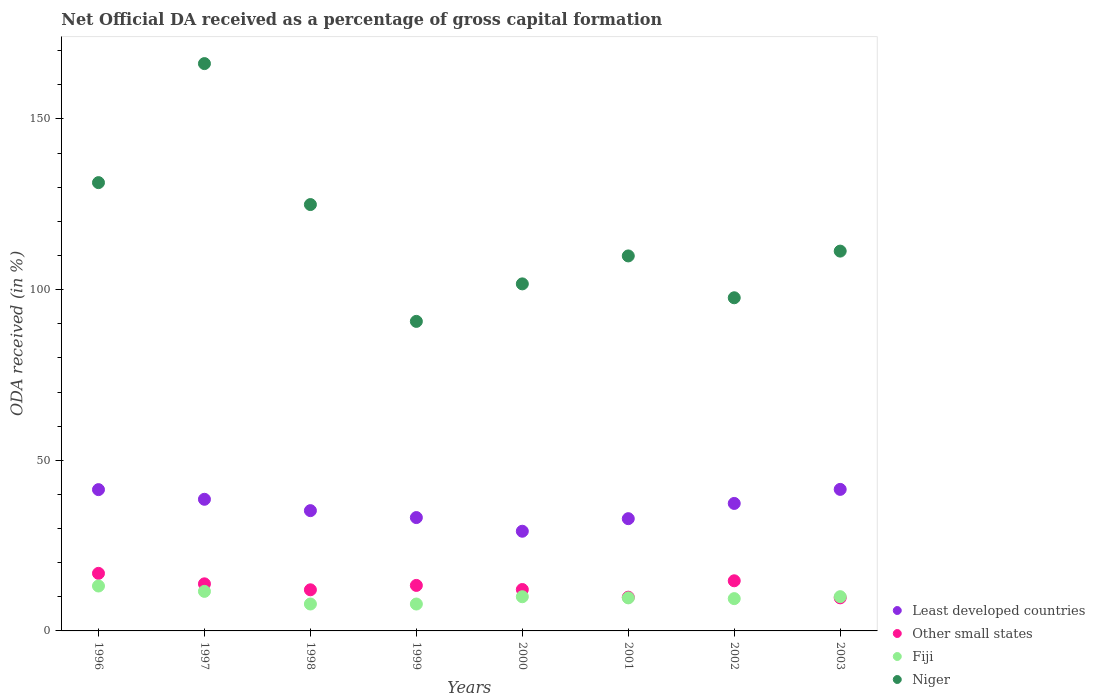Is the number of dotlines equal to the number of legend labels?
Your answer should be very brief. Yes. What is the net ODA received in Least developed countries in 2001?
Your answer should be compact. 32.89. Across all years, what is the maximum net ODA received in Least developed countries?
Your answer should be very brief. 41.47. Across all years, what is the minimum net ODA received in Niger?
Ensure brevity in your answer.  90.69. In which year was the net ODA received in Least developed countries maximum?
Provide a short and direct response. 2003. In which year was the net ODA received in Other small states minimum?
Make the answer very short. 2003. What is the total net ODA received in Other small states in the graph?
Provide a short and direct response. 102.44. What is the difference between the net ODA received in Other small states in 1996 and that in 2001?
Keep it short and to the point. 6.98. What is the difference between the net ODA received in Least developed countries in 2000 and the net ODA received in Fiji in 1996?
Your answer should be very brief. 16.05. What is the average net ODA received in Other small states per year?
Offer a very short reply. 12.8. In the year 1996, what is the difference between the net ODA received in Least developed countries and net ODA received in Other small states?
Provide a succinct answer. 24.53. In how many years, is the net ODA received in Fiji greater than 50 %?
Keep it short and to the point. 0. What is the ratio of the net ODA received in Niger in 1996 to that in 1999?
Offer a very short reply. 1.45. Is the difference between the net ODA received in Least developed countries in 2002 and 2003 greater than the difference between the net ODA received in Other small states in 2002 and 2003?
Provide a short and direct response. No. What is the difference between the highest and the second highest net ODA received in Least developed countries?
Provide a succinct answer. 0.07. What is the difference between the highest and the lowest net ODA received in Least developed countries?
Offer a very short reply. 12.26. In how many years, is the net ODA received in Niger greater than the average net ODA received in Niger taken over all years?
Provide a short and direct response. 3. Is it the case that in every year, the sum of the net ODA received in Niger and net ODA received in Other small states  is greater than the sum of net ODA received in Fiji and net ODA received in Least developed countries?
Ensure brevity in your answer.  Yes. Is it the case that in every year, the sum of the net ODA received in Other small states and net ODA received in Least developed countries  is greater than the net ODA received in Niger?
Offer a very short reply. No. Does the net ODA received in Fiji monotonically increase over the years?
Your answer should be compact. No. Is the net ODA received in Other small states strictly greater than the net ODA received in Niger over the years?
Your answer should be very brief. No. Is the net ODA received in Least developed countries strictly less than the net ODA received in Fiji over the years?
Give a very brief answer. No. How many dotlines are there?
Provide a succinct answer. 4. What is the difference between two consecutive major ticks on the Y-axis?
Provide a short and direct response. 50. Where does the legend appear in the graph?
Offer a very short reply. Bottom right. How many legend labels are there?
Ensure brevity in your answer.  4. How are the legend labels stacked?
Provide a short and direct response. Vertical. What is the title of the graph?
Offer a very short reply. Net Official DA received as a percentage of gross capital formation. Does "Guatemala" appear as one of the legend labels in the graph?
Your answer should be compact. No. What is the label or title of the X-axis?
Provide a short and direct response. Years. What is the label or title of the Y-axis?
Give a very brief answer. ODA received (in %). What is the ODA received (in %) of Least developed countries in 1996?
Ensure brevity in your answer.  41.4. What is the ODA received (in %) in Other small states in 1996?
Provide a succinct answer. 16.87. What is the ODA received (in %) in Fiji in 1996?
Provide a succinct answer. 13.16. What is the ODA received (in %) of Niger in 1996?
Offer a terse response. 131.35. What is the ODA received (in %) in Least developed countries in 1997?
Offer a terse response. 38.57. What is the ODA received (in %) of Other small states in 1997?
Provide a short and direct response. 13.8. What is the ODA received (in %) in Fiji in 1997?
Offer a terse response. 11.59. What is the ODA received (in %) in Niger in 1997?
Ensure brevity in your answer.  166.22. What is the ODA received (in %) in Least developed countries in 1998?
Provide a succinct answer. 35.24. What is the ODA received (in %) in Other small states in 1998?
Ensure brevity in your answer.  12.05. What is the ODA received (in %) of Fiji in 1998?
Keep it short and to the point. 7.89. What is the ODA received (in %) of Niger in 1998?
Offer a very short reply. 124.92. What is the ODA received (in %) in Least developed countries in 1999?
Make the answer very short. 33.21. What is the ODA received (in %) in Other small states in 1999?
Your answer should be compact. 13.33. What is the ODA received (in %) of Fiji in 1999?
Your answer should be very brief. 7.88. What is the ODA received (in %) in Niger in 1999?
Offer a terse response. 90.69. What is the ODA received (in %) in Least developed countries in 2000?
Your answer should be very brief. 29.21. What is the ODA received (in %) of Other small states in 2000?
Ensure brevity in your answer.  12.13. What is the ODA received (in %) in Fiji in 2000?
Your answer should be very brief. 10.02. What is the ODA received (in %) in Niger in 2000?
Give a very brief answer. 101.68. What is the ODA received (in %) of Least developed countries in 2001?
Give a very brief answer. 32.89. What is the ODA received (in %) in Other small states in 2001?
Give a very brief answer. 9.89. What is the ODA received (in %) in Fiji in 2001?
Offer a very short reply. 9.68. What is the ODA received (in %) in Niger in 2001?
Keep it short and to the point. 109.87. What is the ODA received (in %) in Least developed countries in 2002?
Provide a succinct answer. 37.35. What is the ODA received (in %) in Other small states in 2002?
Your answer should be compact. 14.69. What is the ODA received (in %) in Fiji in 2002?
Your answer should be very brief. 9.46. What is the ODA received (in %) of Niger in 2002?
Your answer should be compact. 97.61. What is the ODA received (in %) of Least developed countries in 2003?
Give a very brief answer. 41.47. What is the ODA received (in %) in Other small states in 2003?
Provide a succinct answer. 9.69. What is the ODA received (in %) in Fiji in 2003?
Provide a short and direct response. 10.04. What is the ODA received (in %) of Niger in 2003?
Offer a terse response. 111.28. Across all years, what is the maximum ODA received (in %) in Least developed countries?
Ensure brevity in your answer.  41.47. Across all years, what is the maximum ODA received (in %) in Other small states?
Offer a terse response. 16.87. Across all years, what is the maximum ODA received (in %) in Fiji?
Your response must be concise. 13.16. Across all years, what is the maximum ODA received (in %) in Niger?
Offer a very short reply. 166.22. Across all years, what is the minimum ODA received (in %) of Least developed countries?
Give a very brief answer. 29.21. Across all years, what is the minimum ODA received (in %) in Other small states?
Offer a very short reply. 9.69. Across all years, what is the minimum ODA received (in %) of Fiji?
Your response must be concise. 7.88. Across all years, what is the minimum ODA received (in %) in Niger?
Provide a succinct answer. 90.69. What is the total ODA received (in %) of Least developed countries in the graph?
Offer a terse response. 289.34. What is the total ODA received (in %) of Other small states in the graph?
Make the answer very short. 102.44. What is the total ODA received (in %) of Fiji in the graph?
Provide a short and direct response. 79.71. What is the total ODA received (in %) in Niger in the graph?
Make the answer very short. 933.63. What is the difference between the ODA received (in %) of Least developed countries in 1996 and that in 1997?
Your response must be concise. 2.83. What is the difference between the ODA received (in %) of Other small states in 1996 and that in 1997?
Make the answer very short. 3.07. What is the difference between the ODA received (in %) of Fiji in 1996 and that in 1997?
Keep it short and to the point. 1.57. What is the difference between the ODA received (in %) in Niger in 1996 and that in 1997?
Offer a terse response. -34.87. What is the difference between the ODA received (in %) in Least developed countries in 1996 and that in 1998?
Offer a terse response. 6.16. What is the difference between the ODA received (in %) in Other small states in 1996 and that in 1998?
Make the answer very short. 4.82. What is the difference between the ODA received (in %) in Fiji in 1996 and that in 1998?
Make the answer very short. 5.27. What is the difference between the ODA received (in %) in Niger in 1996 and that in 1998?
Ensure brevity in your answer.  6.43. What is the difference between the ODA received (in %) of Least developed countries in 1996 and that in 1999?
Ensure brevity in your answer.  8.19. What is the difference between the ODA received (in %) in Other small states in 1996 and that in 1999?
Ensure brevity in your answer.  3.53. What is the difference between the ODA received (in %) in Fiji in 1996 and that in 1999?
Give a very brief answer. 5.28. What is the difference between the ODA received (in %) in Niger in 1996 and that in 1999?
Keep it short and to the point. 40.66. What is the difference between the ODA received (in %) in Least developed countries in 1996 and that in 2000?
Keep it short and to the point. 12.19. What is the difference between the ODA received (in %) in Other small states in 1996 and that in 2000?
Your response must be concise. 4.74. What is the difference between the ODA received (in %) of Fiji in 1996 and that in 2000?
Your response must be concise. 3.14. What is the difference between the ODA received (in %) of Niger in 1996 and that in 2000?
Ensure brevity in your answer.  29.67. What is the difference between the ODA received (in %) in Least developed countries in 1996 and that in 2001?
Offer a terse response. 8.51. What is the difference between the ODA received (in %) of Other small states in 1996 and that in 2001?
Provide a succinct answer. 6.98. What is the difference between the ODA received (in %) of Fiji in 1996 and that in 2001?
Give a very brief answer. 3.47. What is the difference between the ODA received (in %) in Niger in 1996 and that in 2001?
Keep it short and to the point. 21.48. What is the difference between the ODA received (in %) of Least developed countries in 1996 and that in 2002?
Your response must be concise. 4.05. What is the difference between the ODA received (in %) of Other small states in 1996 and that in 2002?
Your answer should be compact. 2.18. What is the difference between the ODA received (in %) in Fiji in 1996 and that in 2002?
Keep it short and to the point. 3.7. What is the difference between the ODA received (in %) in Niger in 1996 and that in 2002?
Offer a very short reply. 33.74. What is the difference between the ODA received (in %) of Least developed countries in 1996 and that in 2003?
Keep it short and to the point. -0.07. What is the difference between the ODA received (in %) of Other small states in 1996 and that in 2003?
Provide a succinct answer. 7.17. What is the difference between the ODA received (in %) of Fiji in 1996 and that in 2003?
Your answer should be very brief. 3.12. What is the difference between the ODA received (in %) of Niger in 1996 and that in 2003?
Your response must be concise. 20.07. What is the difference between the ODA received (in %) of Least developed countries in 1997 and that in 1998?
Keep it short and to the point. 3.33. What is the difference between the ODA received (in %) of Other small states in 1997 and that in 1998?
Offer a terse response. 1.75. What is the difference between the ODA received (in %) in Fiji in 1997 and that in 1998?
Offer a terse response. 3.7. What is the difference between the ODA received (in %) in Niger in 1997 and that in 1998?
Offer a terse response. 41.3. What is the difference between the ODA received (in %) of Least developed countries in 1997 and that in 1999?
Your answer should be very brief. 5.36. What is the difference between the ODA received (in %) in Other small states in 1997 and that in 1999?
Provide a short and direct response. 0.46. What is the difference between the ODA received (in %) of Fiji in 1997 and that in 1999?
Offer a very short reply. 3.71. What is the difference between the ODA received (in %) in Niger in 1997 and that in 1999?
Make the answer very short. 75.53. What is the difference between the ODA received (in %) of Least developed countries in 1997 and that in 2000?
Your response must be concise. 9.36. What is the difference between the ODA received (in %) in Other small states in 1997 and that in 2000?
Make the answer very short. 1.67. What is the difference between the ODA received (in %) of Fiji in 1997 and that in 2000?
Keep it short and to the point. 1.57. What is the difference between the ODA received (in %) of Niger in 1997 and that in 2000?
Your answer should be compact. 64.54. What is the difference between the ODA received (in %) of Least developed countries in 1997 and that in 2001?
Keep it short and to the point. 5.68. What is the difference between the ODA received (in %) of Other small states in 1997 and that in 2001?
Your answer should be compact. 3.91. What is the difference between the ODA received (in %) in Fiji in 1997 and that in 2001?
Your answer should be compact. 1.91. What is the difference between the ODA received (in %) of Niger in 1997 and that in 2001?
Your answer should be compact. 56.35. What is the difference between the ODA received (in %) of Least developed countries in 1997 and that in 2002?
Make the answer very short. 1.22. What is the difference between the ODA received (in %) in Other small states in 1997 and that in 2002?
Offer a very short reply. -0.89. What is the difference between the ODA received (in %) in Fiji in 1997 and that in 2002?
Ensure brevity in your answer.  2.13. What is the difference between the ODA received (in %) in Niger in 1997 and that in 2002?
Give a very brief answer. 68.61. What is the difference between the ODA received (in %) of Least developed countries in 1997 and that in 2003?
Make the answer very short. -2.9. What is the difference between the ODA received (in %) of Other small states in 1997 and that in 2003?
Your response must be concise. 4.1. What is the difference between the ODA received (in %) in Fiji in 1997 and that in 2003?
Provide a short and direct response. 1.55. What is the difference between the ODA received (in %) of Niger in 1997 and that in 2003?
Give a very brief answer. 54.94. What is the difference between the ODA received (in %) of Least developed countries in 1998 and that in 1999?
Give a very brief answer. 2.03. What is the difference between the ODA received (in %) in Other small states in 1998 and that in 1999?
Give a very brief answer. -1.28. What is the difference between the ODA received (in %) of Fiji in 1998 and that in 1999?
Offer a very short reply. 0.01. What is the difference between the ODA received (in %) of Niger in 1998 and that in 1999?
Your answer should be compact. 34.23. What is the difference between the ODA received (in %) in Least developed countries in 1998 and that in 2000?
Your answer should be very brief. 6.04. What is the difference between the ODA received (in %) of Other small states in 1998 and that in 2000?
Give a very brief answer. -0.08. What is the difference between the ODA received (in %) in Fiji in 1998 and that in 2000?
Keep it short and to the point. -2.13. What is the difference between the ODA received (in %) in Niger in 1998 and that in 2000?
Provide a succinct answer. 23.24. What is the difference between the ODA received (in %) in Least developed countries in 1998 and that in 2001?
Your response must be concise. 2.35. What is the difference between the ODA received (in %) of Other small states in 1998 and that in 2001?
Offer a very short reply. 2.16. What is the difference between the ODA received (in %) in Fiji in 1998 and that in 2001?
Your answer should be very brief. -1.8. What is the difference between the ODA received (in %) in Niger in 1998 and that in 2001?
Ensure brevity in your answer.  15.05. What is the difference between the ODA received (in %) of Least developed countries in 1998 and that in 2002?
Your response must be concise. -2.11. What is the difference between the ODA received (in %) in Other small states in 1998 and that in 2002?
Provide a short and direct response. -2.64. What is the difference between the ODA received (in %) of Fiji in 1998 and that in 2002?
Provide a short and direct response. -1.58. What is the difference between the ODA received (in %) of Niger in 1998 and that in 2002?
Keep it short and to the point. 27.31. What is the difference between the ODA received (in %) in Least developed countries in 1998 and that in 2003?
Your response must be concise. -6.23. What is the difference between the ODA received (in %) in Other small states in 1998 and that in 2003?
Offer a terse response. 2.36. What is the difference between the ODA received (in %) of Fiji in 1998 and that in 2003?
Keep it short and to the point. -2.15. What is the difference between the ODA received (in %) of Niger in 1998 and that in 2003?
Your answer should be compact. 13.64. What is the difference between the ODA received (in %) of Least developed countries in 1999 and that in 2000?
Keep it short and to the point. 4.01. What is the difference between the ODA received (in %) of Other small states in 1999 and that in 2000?
Your answer should be very brief. 1.2. What is the difference between the ODA received (in %) in Fiji in 1999 and that in 2000?
Your answer should be compact. -2.14. What is the difference between the ODA received (in %) in Niger in 1999 and that in 2000?
Your answer should be compact. -10.99. What is the difference between the ODA received (in %) of Least developed countries in 1999 and that in 2001?
Provide a short and direct response. 0.32. What is the difference between the ODA received (in %) of Other small states in 1999 and that in 2001?
Keep it short and to the point. 3.45. What is the difference between the ODA received (in %) in Fiji in 1999 and that in 2001?
Your answer should be compact. -1.8. What is the difference between the ODA received (in %) of Niger in 1999 and that in 2001?
Your response must be concise. -19.18. What is the difference between the ODA received (in %) of Least developed countries in 1999 and that in 2002?
Give a very brief answer. -4.14. What is the difference between the ODA received (in %) in Other small states in 1999 and that in 2002?
Your answer should be compact. -1.36. What is the difference between the ODA received (in %) of Fiji in 1999 and that in 2002?
Provide a succinct answer. -1.58. What is the difference between the ODA received (in %) in Niger in 1999 and that in 2002?
Your answer should be compact. -6.92. What is the difference between the ODA received (in %) in Least developed countries in 1999 and that in 2003?
Provide a short and direct response. -8.26. What is the difference between the ODA received (in %) in Other small states in 1999 and that in 2003?
Make the answer very short. 3.64. What is the difference between the ODA received (in %) of Fiji in 1999 and that in 2003?
Your answer should be compact. -2.16. What is the difference between the ODA received (in %) of Niger in 1999 and that in 2003?
Keep it short and to the point. -20.59. What is the difference between the ODA received (in %) in Least developed countries in 2000 and that in 2001?
Give a very brief answer. -3.68. What is the difference between the ODA received (in %) in Other small states in 2000 and that in 2001?
Make the answer very short. 2.24. What is the difference between the ODA received (in %) of Fiji in 2000 and that in 2001?
Ensure brevity in your answer.  0.33. What is the difference between the ODA received (in %) of Niger in 2000 and that in 2001?
Provide a short and direct response. -8.19. What is the difference between the ODA received (in %) in Least developed countries in 2000 and that in 2002?
Make the answer very short. -8.15. What is the difference between the ODA received (in %) in Other small states in 2000 and that in 2002?
Your answer should be very brief. -2.56. What is the difference between the ODA received (in %) in Fiji in 2000 and that in 2002?
Offer a terse response. 0.55. What is the difference between the ODA received (in %) of Niger in 2000 and that in 2002?
Make the answer very short. 4.07. What is the difference between the ODA received (in %) in Least developed countries in 2000 and that in 2003?
Offer a terse response. -12.26. What is the difference between the ODA received (in %) in Other small states in 2000 and that in 2003?
Your answer should be compact. 2.43. What is the difference between the ODA received (in %) in Fiji in 2000 and that in 2003?
Give a very brief answer. -0.02. What is the difference between the ODA received (in %) of Niger in 2000 and that in 2003?
Ensure brevity in your answer.  -9.6. What is the difference between the ODA received (in %) in Least developed countries in 2001 and that in 2002?
Your response must be concise. -4.47. What is the difference between the ODA received (in %) of Other small states in 2001 and that in 2002?
Offer a terse response. -4.8. What is the difference between the ODA received (in %) of Fiji in 2001 and that in 2002?
Your response must be concise. 0.22. What is the difference between the ODA received (in %) of Niger in 2001 and that in 2002?
Your answer should be compact. 12.26. What is the difference between the ODA received (in %) of Least developed countries in 2001 and that in 2003?
Offer a very short reply. -8.58. What is the difference between the ODA received (in %) of Other small states in 2001 and that in 2003?
Offer a very short reply. 0.19. What is the difference between the ODA received (in %) of Fiji in 2001 and that in 2003?
Give a very brief answer. -0.35. What is the difference between the ODA received (in %) of Niger in 2001 and that in 2003?
Give a very brief answer. -1.41. What is the difference between the ODA received (in %) of Least developed countries in 2002 and that in 2003?
Offer a terse response. -4.11. What is the difference between the ODA received (in %) in Other small states in 2002 and that in 2003?
Offer a very short reply. 5. What is the difference between the ODA received (in %) in Fiji in 2002 and that in 2003?
Provide a succinct answer. -0.57. What is the difference between the ODA received (in %) of Niger in 2002 and that in 2003?
Make the answer very short. -13.67. What is the difference between the ODA received (in %) of Least developed countries in 1996 and the ODA received (in %) of Other small states in 1997?
Your answer should be very brief. 27.6. What is the difference between the ODA received (in %) of Least developed countries in 1996 and the ODA received (in %) of Fiji in 1997?
Your answer should be compact. 29.81. What is the difference between the ODA received (in %) of Least developed countries in 1996 and the ODA received (in %) of Niger in 1997?
Make the answer very short. -124.82. What is the difference between the ODA received (in %) in Other small states in 1996 and the ODA received (in %) in Fiji in 1997?
Your answer should be very brief. 5.28. What is the difference between the ODA received (in %) in Other small states in 1996 and the ODA received (in %) in Niger in 1997?
Keep it short and to the point. -149.36. What is the difference between the ODA received (in %) in Fiji in 1996 and the ODA received (in %) in Niger in 1997?
Offer a very short reply. -153.06. What is the difference between the ODA received (in %) of Least developed countries in 1996 and the ODA received (in %) of Other small states in 1998?
Give a very brief answer. 29.35. What is the difference between the ODA received (in %) of Least developed countries in 1996 and the ODA received (in %) of Fiji in 1998?
Ensure brevity in your answer.  33.51. What is the difference between the ODA received (in %) of Least developed countries in 1996 and the ODA received (in %) of Niger in 1998?
Your answer should be compact. -83.52. What is the difference between the ODA received (in %) of Other small states in 1996 and the ODA received (in %) of Fiji in 1998?
Make the answer very short. 8.98. What is the difference between the ODA received (in %) of Other small states in 1996 and the ODA received (in %) of Niger in 1998?
Your answer should be very brief. -108.06. What is the difference between the ODA received (in %) in Fiji in 1996 and the ODA received (in %) in Niger in 1998?
Give a very brief answer. -111.76. What is the difference between the ODA received (in %) in Least developed countries in 1996 and the ODA received (in %) in Other small states in 1999?
Make the answer very short. 28.07. What is the difference between the ODA received (in %) of Least developed countries in 1996 and the ODA received (in %) of Fiji in 1999?
Your response must be concise. 33.52. What is the difference between the ODA received (in %) in Least developed countries in 1996 and the ODA received (in %) in Niger in 1999?
Give a very brief answer. -49.29. What is the difference between the ODA received (in %) of Other small states in 1996 and the ODA received (in %) of Fiji in 1999?
Your answer should be very brief. 8.99. What is the difference between the ODA received (in %) in Other small states in 1996 and the ODA received (in %) in Niger in 1999?
Your answer should be very brief. -73.83. What is the difference between the ODA received (in %) of Fiji in 1996 and the ODA received (in %) of Niger in 1999?
Your answer should be very brief. -77.53. What is the difference between the ODA received (in %) of Least developed countries in 1996 and the ODA received (in %) of Other small states in 2000?
Keep it short and to the point. 29.27. What is the difference between the ODA received (in %) in Least developed countries in 1996 and the ODA received (in %) in Fiji in 2000?
Give a very brief answer. 31.38. What is the difference between the ODA received (in %) in Least developed countries in 1996 and the ODA received (in %) in Niger in 2000?
Offer a terse response. -60.28. What is the difference between the ODA received (in %) of Other small states in 1996 and the ODA received (in %) of Fiji in 2000?
Give a very brief answer. 6.85. What is the difference between the ODA received (in %) of Other small states in 1996 and the ODA received (in %) of Niger in 2000?
Give a very brief answer. -84.82. What is the difference between the ODA received (in %) of Fiji in 1996 and the ODA received (in %) of Niger in 2000?
Give a very brief answer. -88.52. What is the difference between the ODA received (in %) of Least developed countries in 1996 and the ODA received (in %) of Other small states in 2001?
Make the answer very short. 31.51. What is the difference between the ODA received (in %) in Least developed countries in 1996 and the ODA received (in %) in Fiji in 2001?
Provide a succinct answer. 31.71. What is the difference between the ODA received (in %) in Least developed countries in 1996 and the ODA received (in %) in Niger in 2001?
Your answer should be compact. -68.47. What is the difference between the ODA received (in %) of Other small states in 1996 and the ODA received (in %) of Fiji in 2001?
Ensure brevity in your answer.  7.18. What is the difference between the ODA received (in %) of Other small states in 1996 and the ODA received (in %) of Niger in 2001?
Keep it short and to the point. -93.01. What is the difference between the ODA received (in %) in Fiji in 1996 and the ODA received (in %) in Niger in 2001?
Make the answer very short. -96.71. What is the difference between the ODA received (in %) in Least developed countries in 1996 and the ODA received (in %) in Other small states in 2002?
Ensure brevity in your answer.  26.71. What is the difference between the ODA received (in %) in Least developed countries in 1996 and the ODA received (in %) in Fiji in 2002?
Make the answer very short. 31.94. What is the difference between the ODA received (in %) of Least developed countries in 1996 and the ODA received (in %) of Niger in 2002?
Give a very brief answer. -56.21. What is the difference between the ODA received (in %) in Other small states in 1996 and the ODA received (in %) in Fiji in 2002?
Your answer should be compact. 7.4. What is the difference between the ODA received (in %) in Other small states in 1996 and the ODA received (in %) in Niger in 2002?
Your answer should be very brief. -80.75. What is the difference between the ODA received (in %) of Fiji in 1996 and the ODA received (in %) of Niger in 2002?
Provide a short and direct response. -84.45. What is the difference between the ODA received (in %) of Least developed countries in 1996 and the ODA received (in %) of Other small states in 2003?
Provide a succinct answer. 31.71. What is the difference between the ODA received (in %) in Least developed countries in 1996 and the ODA received (in %) in Fiji in 2003?
Your answer should be compact. 31.36. What is the difference between the ODA received (in %) in Least developed countries in 1996 and the ODA received (in %) in Niger in 2003?
Provide a short and direct response. -69.88. What is the difference between the ODA received (in %) in Other small states in 1996 and the ODA received (in %) in Fiji in 2003?
Offer a very short reply. 6.83. What is the difference between the ODA received (in %) in Other small states in 1996 and the ODA received (in %) in Niger in 2003?
Offer a very short reply. -94.42. What is the difference between the ODA received (in %) of Fiji in 1996 and the ODA received (in %) of Niger in 2003?
Ensure brevity in your answer.  -98.12. What is the difference between the ODA received (in %) of Least developed countries in 1997 and the ODA received (in %) of Other small states in 1998?
Ensure brevity in your answer.  26.52. What is the difference between the ODA received (in %) of Least developed countries in 1997 and the ODA received (in %) of Fiji in 1998?
Provide a short and direct response. 30.68. What is the difference between the ODA received (in %) of Least developed countries in 1997 and the ODA received (in %) of Niger in 1998?
Your answer should be very brief. -86.35. What is the difference between the ODA received (in %) of Other small states in 1997 and the ODA received (in %) of Fiji in 1998?
Give a very brief answer. 5.91. What is the difference between the ODA received (in %) of Other small states in 1997 and the ODA received (in %) of Niger in 1998?
Give a very brief answer. -111.13. What is the difference between the ODA received (in %) in Fiji in 1997 and the ODA received (in %) in Niger in 1998?
Give a very brief answer. -113.33. What is the difference between the ODA received (in %) of Least developed countries in 1997 and the ODA received (in %) of Other small states in 1999?
Offer a very short reply. 25.24. What is the difference between the ODA received (in %) of Least developed countries in 1997 and the ODA received (in %) of Fiji in 1999?
Provide a short and direct response. 30.69. What is the difference between the ODA received (in %) in Least developed countries in 1997 and the ODA received (in %) in Niger in 1999?
Make the answer very short. -52.12. What is the difference between the ODA received (in %) of Other small states in 1997 and the ODA received (in %) of Fiji in 1999?
Make the answer very short. 5.92. What is the difference between the ODA received (in %) of Other small states in 1997 and the ODA received (in %) of Niger in 1999?
Give a very brief answer. -76.9. What is the difference between the ODA received (in %) in Fiji in 1997 and the ODA received (in %) in Niger in 1999?
Offer a terse response. -79.1. What is the difference between the ODA received (in %) in Least developed countries in 1997 and the ODA received (in %) in Other small states in 2000?
Make the answer very short. 26.44. What is the difference between the ODA received (in %) in Least developed countries in 1997 and the ODA received (in %) in Fiji in 2000?
Offer a terse response. 28.55. What is the difference between the ODA received (in %) of Least developed countries in 1997 and the ODA received (in %) of Niger in 2000?
Your answer should be compact. -63.11. What is the difference between the ODA received (in %) of Other small states in 1997 and the ODA received (in %) of Fiji in 2000?
Ensure brevity in your answer.  3.78. What is the difference between the ODA received (in %) of Other small states in 1997 and the ODA received (in %) of Niger in 2000?
Offer a very short reply. -87.89. What is the difference between the ODA received (in %) of Fiji in 1997 and the ODA received (in %) of Niger in 2000?
Ensure brevity in your answer.  -90.09. What is the difference between the ODA received (in %) in Least developed countries in 1997 and the ODA received (in %) in Other small states in 2001?
Offer a terse response. 28.68. What is the difference between the ODA received (in %) in Least developed countries in 1997 and the ODA received (in %) in Fiji in 2001?
Your answer should be very brief. 28.89. What is the difference between the ODA received (in %) in Least developed countries in 1997 and the ODA received (in %) in Niger in 2001?
Your answer should be compact. -71.3. What is the difference between the ODA received (in %) in Other small states in 1997 and the ODA received (in %) in Fiji in 2001?
Keep it short and to the point. 4.11. What is the difference between the ODA received (in %) of Other small states in 1997 and the ODA received (in %) of Niger in 2001?
Your answer should be compact. -96.07. What is the difference between the ODA received (in %) in Fiji in 1997 and the ODA received (in %) in Niger in 2001?
Provide a succinct answer. -98.28. What is the difference between the ODA received (in %) of Least developed countries in 1997 and the ODA received (in %) of Other small states in 2002?
Ensure brevity in your answer.  23.88. What is the difference between the ODA received (in %) of Least developed countries in 1997 and the ODA received (in %) of Fiji in 2002?
Offer a terse response. 29.11. What is the difference between the ODA received (in %) in Least developed countries in 1997 and the ODA received (in %) in Niger in 2002?
Your response must be concise. -59.04. What is the difference between the ODA received (in %) of Other small states in 1997 and the ODA received (in %) of Fiji in 2002?
Make the answer very short. 4.33. What is the difference between the ODA received (in %) of Other small states in 1997 and the ODA received (in %) of Niger in 2002?
Your response must be concise. -83.82. What is the difference between the ODA received (in %) in Fiji in 1997 and the ODA received (in %) in Niger in 2002?
Your answer should be compact. -86.02. What is the difference between the ODA received (in %) in Least developed countries in 1997 and the ODA received (in %) in Other small states in 2003?
Provide a succinct answer. 28.88. What is the difference between the ODA received (in %) in Least developed countries in 1997 and the ODA received (in %) in Fiji in 2003?
Provide a short and direct response. 28.53. What is the difference between the ODA received (in %) of Least developed countries in 1997 and the ODA received (in %) of Niger in 2003?
Give a very brief answer. -72.71. What is the difference between the ODA received (in %) in Other small states in 1997 and the ODA received (in %) in Fiji in 2003?
Your response must be concise. 3.76. What is the difference between the ODA received (in %) of Other small states in 1997 and the ODA received (in %) of Niger in 2003?
Provide a short and direct response. -97.49. What is the difference between the ODA received (in %) in Fiji in 1997 and the ODA received (in %) in Niger in 2003?
Offer a very short reply. -99.69. What is the difference between the ODA received (in %) of Least developed countries in 1998 and the ODA received (in %) of Other small states in 1999?
Make the answer very short. 21.91. What is the difference between the ODA received (in %) of Least developed countries in 1998 and the ODA received (in %) of Fiji in 1999?
Make the answer very short. 27.36. What is the difference between the ODA received (in %) in Least developed countries in 1998 and the ODA received (in %) in Niger in 1999?
Provide a short and direct response. -55.45. What is the difference between the ODA received (in %) of Other small states in 1998 and the ODA received (in %) of Fiji in 1999?
Your response must be concise. 4.17. What is the difference between the ODA received (in %) of Other small states in 1998 and the ODA received (in %) of Niger in 1999?
Your response must be concise. -78.64. What is the difference between the ODA received (in %) of Fiji in 1998 and the ODA received (in %) of Niger in 1999?
Ensure brevity in your answer.  -82.81. What is the difference between the ODA received (in %) in Least developed countries in 1998 and the ODA received (in %) in Other small states in 2000?
Provide a succinct answer. 23.11. What is the difference between the ODA received (in %) in Least developed countries in 1998 and the ODA received (in %) in Fiji in 2000?
Your answer should be compact. 25.22. What is the difference between the ODA received (in %) in Least developed countries in 1998 and the ODA received (in %) in Niger in 2000?
Provide a short and direct response. -66.44. What is the difference between the ODA received (in %) of Other small states in 1998 and the ODA received (in %) of Fiji in 2000?
Your answer should be very brief. 2.03. What is the difference between the ODA received (in %) in Other small states in 1998 and the ODA received (in %) in Niger in 2000?
Offer a terse response. -89.63. What is the difference between the ODA received (in %) of Fiji in 1998 and the ODA received (in %) of Niger in 2000?
Offer a very short reply. -93.8. What is the difference between the ODA received (in %) in Least developed countries in 1998 and the ODA received (in %) in Other small states in 2001?
Ensure brevity in your answer.  25.35. What is the difference between the ODA received (in %) of Least developed countries in 1998 and the ODA received (in %) of Fiji in 2001?
Your answer should be compact. 25.56. What is the difference between the ODA received (in %) in Least developed countries in 1998 and the ODA received (in %) in Niger in 2001?
Offer a very short reply. -74.63. What is the difference between the ODA received (in %) of Other small states in 1998 and the ODA received (in %) of Fiji in 2001?
Ensure brevity in your answer.  2.36. What is the difference between the ODA received (in %) in Other small states in 1998 and the ODA received (in %) in Niger in 2001?
Offer a very short reply. -97.82. What is the difference between the ODA received (in %) in Fiji in 1998 and the ODA received (in %) in Niger in 2001?
Keep it short and to the point. -101.98. What is the difference between the ODA received (in %) of Least developed countries in 1998 and the ODA received (in %) of Other small states in 2002?
Ensure brevity in your answer.  20.55. What is the difference between the ODA received (in %) of Least developed countries in 1998 and the ODA received (in %) of Fiji in 2002?
Offer a very short reply. 25.78. What is the difference between the ODA received (in %) of Least developed countries in 1998 and the ODA received (in %) of Niger in 2002?
Provide a short and direct response. -62.37. What is the difference between the ODA received (in %) of Other small states in 1998 and the ODA received (in %) of Fiji in 2002?
Offer a terse response. 2.59. What is the difference between the ODA received (in %) in Other small states in 1998 and the ODA received (in %) in Niger in 2002?
Your answer should be very brief. -85.56. What is the difference between the ODA received (in %) in Fiji in 1998 and the ODA received (in %) in Niger in 2002?
Your response must be concise. -89.73. What is the difference between the ODA received (in %) in Least developed countries in 1998 and the ODA received (in %) in Other small states in 2003?
Your response must be concise. 25.55. What is the difference between the ODA received (in %) in Least developed countries in 1998 and the ODA received (in %) in Fiji in 2003?
Offer a very short reply. 25.21. What is the difference between the ODA received (in %) in Least developed countries in 1998 and the ODA received (in %) in Niger in 2003?
Give a very brief answer. -76.04. What is the difference between the ODA received (in %) in Other small states in 1998 and the ODA received (in %) in Fiji in 2003?
Your response must be concise. 2.01. What is the difference between the ODA received (in %) of Other small states in 1998 and the ODA received (in %) of Niger in 2003?
Provide a short and direct response. -99.23. What is the difference between the ODA received (in %) of Fiji in 1998 and the ODA received (in %) of Niger in 2003?
Keep it short and to the point. -103.4. What is the difference between the ODA received (in %) of Least developed countries in 1999 and the ODA received (in %) of Other small states in 2000?
Offer a terse response. 21.08. What is the difference between the ODA received (in %) of Least developed countries in 1999 and the ODA received (in %) of Fiji in 2000?
Give a very brief answer. 23.2. What is the difference between the ODA received (in %) of Least developed countries in 1999 and the ODA received (in %) of Niger in 2000?
Keep it short and to the point. -68.47. What is the difference between the ODA received (in %) in Other small states in 1999 and the ODA received (in %) in Fiji in 2000?
Give a very brief answer. 3.32. What is the difference between the ODA received (in %) in Other small states in 1999 and the ODA received (in %) in Niger in 2000?
Provide a short and direct response. -88.35. What is the difference between the ODA received (in %) of Fiji in 1999 and the ODA received (in %) of Niger in 2000?
Give a very brief answer. -93.8. What is the difference between the ODA received (in %) in Least developed countries in 1999 and the ODA received (in %) in Other small states in 2001?
Offer a very short reply. 23.33. What is the difference between the ODA received (in %) of Least developed countries in 1999 and the ODA received (in %) of Fiji in 2001?
Ensure brevity in your answer.  23.53. What is the difference between the ODA received (in %) of Least developed countries in 1999 and the ODA received (in %) of Niger in 2001?
Provide a succinct answer. -76.66. What is the difference between the ODA received (in %) of Other small states in 1999 and the ODA received (in %) of Fiji in 2001?
Your response must be concise. 3.65. What is the difference between the ODA received (in %) of Other small states in 1999 and the ODA received (in %) of Niger in 2001?
Make the answer very short. -96.54. What is the difference between the ODA received (in %) of Fiji in 1999 and the ODA received (in %) of Niger in 2001?
Your answer should be very brief. -101.99. What is the difference between the ODA received (in %) of Least developed countries in 1999 and the ODA received (in %) of Other small states in 2002?
Keep it short and to the point. 18.52. What is the difference between the ODA received (in %) in Least developed countries in 1999 and the ODA received (in %) in Fiji in 2002?
Keep it short and to the point. 23.75. What is the difference between the ODA received (in %) of Least developed countries in 1999 and the ODA received (in %) of Niger in 2002?
Provide a short and direct response. -64.4. What is the difference between the ODA received (in %) of Other small states in 1999 and the ODA received (in %) of Fiji in 2002?
Make the answer very short. 3.87. What is the difference between the ODA received (in %) in Other small states in 1999 and the ODA received (in %) in Niger in 2002?
Offer a terse response. -84.28. What is the difference between the ODA received (in %) in Fiji in 1999 and the ODA received (in %) in Niger in 2002?
Give a very brief answer. -89.73. What is the difference between the ODA received (in %) in Least developed countries in 1999 and the ODA received (in %) in Other small states in 2003?
Offer a very short reply. 23.52. What is the difference between the ODA received (in %) of Least developed countries in 1999 and the ODA received (in %) of Fiji in 2003?
Your answer should be very brief. 23.18. What is the difference between the ODA received (in %) in Least developed countries in 1999 and the ODA received (in %) in Niger in 2003?
Give a very brief answer. -78.07. What is the difference between the ODA received (in %) in Other small states in 1999 and the ODA received (in %) in Fiji in 2003?
Provide a short and direct response. 3.3. What is the difference between the ODA received (in %) of Other small states in 1999 and the ODA received (in %) of Niger in 2003?
Keep it short and to the point. -97.95. What is the difference between the ODA received (in %) of Fiji in 1999 and the ODA received (in %) of Niger in 2003?
Your answer should be very brief. -103.4. What is the difference between the ODA received (in %) in Least developed countries in 2000 and the ODA received (in %) in Other small states in 2001?
Ensure brevity in your answer.  19.32. What is the difference between the ODA received (in %) in Least developed countries in 2000 and the ODA received (in %) in Fiji in 2001?
Offer a very short reply. 19.52. What is the difference between the ODA received (in %) in Least developed countries in 2000 and the ODA received (in %) in Niger in 2001?
Provide a succinct answer. -80.67. What is the difference between the ODA received (in %) of Other small states in 2000 and the ODA received (in %) of Fiji in 2001?
Make the answer very short. 2.44. What is the difference between the ODA received (in %) in Other small states in 2000 and the ODA received (in %) in Niger in 2001?
Your answer should be compact. -97.74. What is the difference between the ODA received (in %) of Fiji in 2000 and the ODA received (in %) of Niger in 2001?
Provide a succinct answer. -99.85. What is the difference between the ODA received (in %) in Least developed countries in 2000 and the ODA received (in %) in Other small states in 2002?
Your response must be concise. 14.52. What is the difference between the ODA received (in %) in Least developed countries in 2000 and the ODA received (in %) in Fiji in 2002?
Provide a short and direct response. 19.74. What is the difference between the ODA received (in %) in Least developed countries in 2000 and the ODA received (in %) in Niger in 2002?
Provide a short and direct response. -68.41. What is the difference between the ODA received (in %) in Other small states in 2000 and the ODA received (in %) in Fiji in 2002?
Your answer should be very brief. 2.67. What is the difference between the ODA received (in %) in Other small states in 2000 and the ODA received (in %) in Niger in 2002?
Your response must be concise. -85.48. What is the difference between the ODA received (in %) in Fiji in 2000 and the ODA received (in %) in Niger in 2002?
Your answer should be very brief. -87.6. What is the difference between the ODA received (in %) in Least developed countries in 2000 and the ODA received (in %) in Other small states in 2003?
Your answer should be very brief. 19.51. What is the difference between the ODA received (in %) in Least developed countries in 2000 and the ODA received (in %) in Fiji in 2003?
Your answer should be compact. 19.17. What is the difference between the ODA received (in %) of Least developed countries in 2000 and the ODA received (in %) of Niger in 2003?
Keep it short and to the point. -82.08. What is the difference between the ODA received (in %) of Other small states in 2000 and the ODA received (in %) of Fiji in 2003?
Make the answer very short. 2.09. What is the difference between the ODA received (in %) of Other small states in 2000 and the ODA received (in %) of Niger in 2003?
Make the answer very short. -99.15. What is the difference between the ODA received (in %) of Fiji in 2000 and the ODA received (in %) of Niger in 2003?
Give a very brief answer. -101.26. What is the difference between the ODA received (in %) of Least developed countries in 2001 and the ODA received (in %) of Other small states in 2002?
Provide a short and direct response. 18.2. What is the difference between the ODA received (in %) of Least developed countries in 2001 and the ODA received (in %) of Fiji in 2002?
Keep it short and to the point. 23.43. What is the difference between the ODA received (in %) of Least developed countries in 2001 and the ODA received (in %) of Niger in 2002?
Offer a terse response. -64.72. What is the difference between the ODA received (in %) of Other small states in 2001 and the ODA received (in %) of Fiji in 2002?
Your response must be concise. 0.42. What is the difference between the ODA received (in %) in Other small states in 2001 and the ODA received (in %) in Niger in 2002?
Provide a succinct answer. -87.73. What is the difference between the ODA received (in %) in Fiji in 2001 and the ODA received (in %) in Niger in 2002?
Provide a short and direct response. -87.93. What is the difference between the ODA received (in %) in Least developed countries in 2001 and the ODA received (in %) in Other small states in 2003?
Your response must be concise. 23.19. What is the difference between the ODA received (in %) of Least developed countries in 2001 and the ODA received (in %) of Fiji in 2003?
Your response must be concise. 22.85. What is the difference between the ODA received (in %) of Least developed countries in 2001 and the ODA received (in %) of Niger in 2003?
Your answer should be very brief. -78.39. What is the difference between the ODA received (in %) in Other small states in 2001 and the ODA received (in %) in Fiji in 2003?
Your answer should be compact. -0.15. What is the difference between the ODA received (in %) in Other small states in 2001 and the ODA received (in %) in Niger in 2003?
Offer a very short reply. -101.4. What is the difference between the ODA received (in %) in Fiji in 2001 and the ODA received (in %) in Niger in 2003?
Your answer should be compact. -101.6. What is the difference between the ODA received (in %) in Least developed countries in 2002 and the ODA received (in %) in Other small states in 2003?
Provide a short and direct response. 27.66. What is the difference between the ODA received (in %) in Least developed countries in 2002 and the ODA received (in %) in Fiji in 2003?
Offer a very short reply. 27.32. What is the difference between the ODA received (in %) of Least developed countries in 2002 and the ODA received (in %) of Niger in 2003?
Provide a short and direct response. -73.93. What is the difference between the ODA received (in %) of Other small states in 2002 and the ODA received (in %) of Fiji in 2003?
Keep it short and to the point. 4.65. What is the difference between the ODA received (in %) of Other small states in 2002 and the ODA received (in %) of Niger in 2003?
Provide a succinct answer. -96.59. What is the difference between the ODA received (in %) in Fiji in 2002 and the ODA received (in %) in Niger in 2003?
Make the answer very short. -101.82. What is the average ODA received (in %) in Least developed countries per year?
Give a very brief answer. 36.17. What is the average ODA received (in %) of Other small states per year?
Give a very brief answer. 12.8. What is the average ODA received (in %) of Fiji per year?
Provide a short and direct response. 9.96. What is the average ODA received (in %) of Niger per year?
Make the answer very short. 116.7. In the year 1996, what is the difference between the ODA received (in %) of Least developed countries and ODA received (in %) of Other small states?
Give a very brief answer. 24.53. In the year 1996, what is the difference between the ODA received (in %) in Least developed countries and ODA received (in %) in Fiji?
Provide a short and direct response. 28.24. In the year 1996, what is the difference between the ODA received (in %) in Least developed countries and ODA received (in %) in Niger?
Offer a very short reply. -89.95. In the year 1996, what is the difference between the ODA received (in %) of Other small states and ODA received (in %) of Fiji?
Offer a terse response. 3.71. In the year 1996, what is the difference between the ODA received (in %) of Other small states and ODA received (in %) of Niger?
Make the answer very short. -114.48. In the year 1996, what is the difference between the ODA received (in %) in Fiji and ODA received (in %) in Niger?
Provide a succinct answer. -118.19. In the year 1997, what is the difference between the ODA received (in %) in Least developed countries and ODA received (in %) in Other small states?
Provide a succinct answer. 24.77. In the year 1997, what is the difference between the ODA received (in %) of Least developed countries and ODA received (in %) of Fiji?
Ensure brevity in your answer.  26.98. In the year 1997, what is the difference between the ODA received (in %) of Least developed countries and ODA received (in %) of Niger?
Offer a terse response. -127.65. In the year 1997, what is the difference between the ODA received (in %) in Other small states and ODA received (in %) in Fiji?
Provide a succinct answer. 2.21. In the year 1997, what is the difference between the ODA received (in %) in Other small states and ODA received (in %) in Niger?
Your answer should be very brief. -152.43. In the year 1997, what is the difference between the ODA received (in %) of Fiji and ODA received (in %) of Niger?
Your answer should be very brief. -154.63. In the year 1998, what is the difference between the ODA received (in %) in Least developed countries and ODA received (in %) in Other small states?
Your answer should be compact. 23.19. In the year 1998, what is the difference between the ODA received (in %) in Least developed countries and ODA received (in %) in Fiji?
Provide a short and direct response. 27.35. In the year 1998, what is the difference between the ODA received (in %) of Least developed countries and ODA received (in %) of Niger?
Your answer should be compact. -89.68. In the year 1998, what is the difference between the ODA received (in %) of Other small states and ODA received (in %) of Fiji?
Make the answer very short. 4.16. In the year 1998, what is the difference between the ODA received (in %) of Other small states and ODA received (in %) of Niger?
Ensure brevity in your answer.  -112.87. In the year 1998, what is the difference between the ODA received (in %) in Fiji and ODA received (in %) in Niger?
Your response must be concise. -117.03. In the year 1999, what is the difference between the ODA received (in %) in Least developed countries and ODA received (in %) in Other small states?
Provide a succinct answer. 19.88. In the year 1999, what is the difference between the ODA received (in %) of Least developed countries and ODA received (in %) of Fiji?
Ensure brevity in your answer.  25.33. In the year 1999, what is the difference between the ODA received (in %) in Least developed countries and ODA received (in %) in Niger?
Your answer should be compact. -57.48. In the year 1999, what is the difference between the ODA received (in %) in Other small states and ODA received (in %) in Fiji?
Your answer should be very brief. 5.45. In the year 1999, what is the difference between the ODA received (in %) of Other small states and ODA received (in %) of Niger?
Your response must be concise. -77.36. In the year 1999, what is the difference between the ODA received (in %) in Fiji and ODA received (in %) in Niger?
Provide a short and direct response. -82.81. In the year 2000, what is the difference between the ODA received (in %) of Least developed countries and ODA received (in %) of Other small states?
Give a very brief answer. 17.08. In the year 2000, what is the difference between the ODA received (in %) in Least developed countries and ODA received (in %) in Fiji?
Your answer should be compact. 19.19. In the year 2000, what is the difference between the ODA received (in %) in Least developed countries and ODA received (in %) in Niger?
Give a very brief answer. -72.48. In the year 2000, what is the difference between the ODA received (in %) in Other small states and ODA received (in %) in Fiji?
Offer a very short reply. 2.11. In the year 2000, what is the difference between the ODA received (in %) in Other small states and ODA received (in %) in Niger?
Offer a terse response. -89.55. In the year 2000, what is the difference between the ODA received (in %) in Fiji and ODA received (in %) in Niger?
Provide a short and direct response. -91.67. In the year 2001, what is the difference between the ODA received (in %) of Least developed countries and ODA received (in %) of Other small states?
Your answer should be compact. 23. In the year 2001, what is the difference between the ODA received (in %) in Least developed countries and ODA received (in %) in Fiji?
Ensure brevity in your answer.  23.2. In the year 2001, what is the difference between the ODA received (in %) in Least developed countries and ODA received (in %) in Niger?
Your response must be concise. -76.98. In the year 2001, what is the difference between the ODA received (in %) in Other small states and ODA received (in %) in Fiji?
Your answer should be very brief. 0.2. In the year 2001, what is the difference between the ODA received (in %) of Other small states and ODA received (in %) of Niger?
Your response must be concise. -99.98. In the year 2001, what is the difference between the ODA received (in %) of Fiji and ODA received (in %) of Niger?
Provide a succinct answer. -100.19. In the year 2002, what is the difference between the ODA received (in %) in Least developed countries and ODA received (in %) in Other small states?
Your response must be concise. 22.66. In the year 2002, what is the difference between the ODA received (in %) in Least developed countries and ODA received (in %) in Fiji?
Give a very brief answer. 27.89. In the year 2002, what is the difference between the ODA received (in %) in Least developed countries and ODA received (in %) in Niger?
Give a very brief answer. -60.26. In the year 2002, what is the difference between the ODA received (in %) in Other small states and ODA received (in %) in Fiji?
Give a very brief answer. 5.23. In the year 2002, what is the difference between the ODA received (in %) of Other small states and ODA received (in %) of Niger?
Offer a very short reply. -82.92. In the year 2002, what is the difference between the ODA received (in %) in Fiji and ODA received (in %) in Niger?
Your response must be concise. -88.15. In the year 2003, what is the difference between the ODA received (in %) in Least developed countries and ODA received (in %) in Other small states?
Your response must be concise. 31.77. In the year 2003, what is the difference between the ODA received (in %) of Least developed countries and ODA received (in %) of Fiji?
Make the answer very short. 31.43. In the year 2003, what is the difference between the ODA received (in %) of Least developed countries and ODA received (in %) of Niger?
Make the answer very short. -69.81. In the year 2003, what is the difference between the ODA received (in %) in Other small states and ODA received (in %) in Fiji?
Provide a short and direct response. -0.34. In the year 2003, what is the difference between the ODA received (in %) of Other small states and ODA received (in %) of Niger?
Provide a short and direct response. -101.59. In the year 2003, what is the difference between the ODA received (in %) in Fiji and ODA received (in %) in Niger?
Give a very brief answer. -101.25. What is the ratio of the ODA received (in %) in Least developed countries in 1996 to that in 1997?
Your response must be concise. 1.07. What is the ratio of the ODA received (in %) of Other small states in 1996 to that in 1997?
Offer a very short reply. 1.22. What is the ratio of the ODA received (in %) in Fiji in 1996 to that in 1997?
Give a very brief answer. 1.14. What is the ratio of the ODA received (in %) of Niger in 1996 to that in 1997?
Provide a short and direct response. 0.79. What is the ratio of the ODA received (in %) of Least developed countries in 1996 to that in 1998?
Your answer should be very brief. 1.17. What is the ratio of the ODA received (in %) of Other small states in 1996 to that in 1998?
Offer a terse response. 1.4. What is the ratio of the ODA received (in %) of Fiji in 1996 to that in 1998?
Ensure brevity in your answer.  1.67. What is the ratio of the ODA received (in %) in Niger in 1996 to that in 1998?
Offer a terse response. 1.05. What is the ratio of the ODA received (in %) of Least developed countries in 1996 to that in 1999?
Provide a succinct answer. 1.25. What is the ratio of the ODA received (in %) in Other small states in 1996 to that in 1999?
Offer a very short reply. 1.26. What is the ratio of the ODA received (in %) in Fiji in 1996 to that in 1999?
Keep it short and to the point. 1.67. What is the ratio of the ODA received (in %) in Niger in 1996 to that in 1999?
Provide a succinct answer. 1.45. What is the ratio of the ODA received (in %) in Least developed countries in 1996 to that in 2000?
Keep it short and to the point. 1.42. What is the ratio of the ODA received (in %) in Other small states in 1996 to that in 2000?
Your response must be concise. 1.39. What is the ratio of the ODA received (in %) in Fiji in 1996 to that in 2000?
Keep it short and to the point. 1.31. What is the ratio of the ODA received (in %) of Niger in 1996 to that in 2000?
Offer a very short reply. 1.29. What is the ratio of the ODA received (in %) in Least developed countries in 1996 to that in 2001?
Your response must be concise. 1.26. What is the ratio of the ODA received (in %) in Other small states in 1996 to that in 2001?
Offer a terse response. 1.71. What is the ratio of the ODA received (in %) in Fiji in 1996 to that in 2001?
Offer a terse response. 1.36. What is the ratio of the ODA received (in %) in Niger in 1996 to that in 2001?
Offer a very short reply. 1.2. What is the ratio of the ODA received (in %) in Least developed countries in 1996 to that in 2002?
Offer a terse response. 1.11. What is the ratio of the ODA received (in %) in Other small states in 1996 to that in 2002?
Make the answer very short. 1.15. What is the ratio of the ODA received (in %) of Fiji in 1996 to that in 2002?
Offer a very short reply. 1.39. What is the ratio of the ODA received (in %) in Niger in 1996 to that in 2002?
Your response must be concise. 1.35. What is the ratio of the ODA received (in %) of Other small states in 1996 to that in 2003?
Give a very brief answer. 1.74. What is the ratio of the ODA received (in %) of Fiji in 1996 to that in 2003?
Offer a terse response. 1.31. What is the ratio of the ODA received (in %) in Niger in 1996 to that in 2003?
Ensure brevity in your answer.  1.18. What is the ratio of the ODA received (in %) in Least developed countries in 1997 to that in 1998?
Make the answer very short. 1.09. What is the ratio of the ODA received (in %) of Other small states in 1997 to that in 1998?
Ensure brevity in your answer.  1.15. What is the ratio of the ODA received (in %) of Fiji in 1997 to that in 1998?
Your response must be concise. 1.47. What is the ratio of the ODA received (in %) in Niger in 1997 to that in 1998?
Offer a very short reply. 1.33. What is the ratio of the ODA received (in %) of Least developed countries in 1997 to that in 1999?
Provide a short and direct response. 1.16. What is the ratio of the ODA received (in %) of Other small states in 1997 to that in 1999?
Your answer should be compact. 1.03. What is the ratio of the ODA received (in %) in Fiji in 1997 to that in 1999?
Provide a succinct answer. 1.47. What is the ratio of the ODA received (in %) in Niger in 1997 to that in 1999?
Ensure brevity in your answer.  1.83. What is the ratio of the ODA received (in %) of Least developed countries in 1997 to that in 2000?
Offer a very short reply. 1.32. What is the ratio of the ODA received (in %) in Other small states in 1997 to that in 2000?
Your response must be concise. 1.14. What is the ratio of the ODA received (in %) of Fiji in 1997 to that in 2000?
Keep it short and to the point. 1.16. What is the ratio of the ODA received (in %) in Niger in 1997 to that in 2000?
Your response must be concise. 1.63. What is the ratio of the ODA received (in %) of Least developed countries in 1997 to that in 2001?
Keep it short and to the point. 1.17. What is the ratio of the ODA received (in %) of Other small states in 1997 to that in 2001?
Your answer should be compact. 1.4. What is the ratio of the ODA received (in %) of Fiji in 1997 to that in 2001?
Offer a terse response. 1.2. What is the ratio of the ODA received (in %) of Niger in 1997 to that in 2001?
Keep it short and to the point. 1.51. What is the ratio of the ODA received (in %) of Least developed countries in 1997 to that in 2002?
Your response must be concise. 1.03. What is the ratio of the ODA received (in %) of Other small states in 1997 to that in 2002?
Offer a very short reply. 0.94. What is the ratio of the ODA received (in %) in Fiji in 1997 to that in 2002?
Your answer should be very brief. 1.22. What is the ratio of the ODA received (in %) of Niger in 1997 to that in 2002?
Ensure brevity in your answer.  1.7. What is the ratio of the ODA received (in %) in Least developed countries in 1997 to that in 2003?
Offer a terse response. 0.93. What is the ratio of the ODA received (in %) in Other small states in 1997 to that in 2003?
Give a very brief answer. 1.42. What is the ratio of the ODA received (in %) in Fiji in 1997 to that in 2003?
Give a very brief answer. 1.15. What is the ratio of the ODA received (in %) of Niger in 1997 to that in 2003?
Keep it short and to the point. 1.49. What is the ratio of the ODA received (in %) in Least developed countries in 1998 to that in 1999?
Offer a very short reply. 1.06. What is the ratio of the ODA received (in %) in Other small states in 1998 to that in 1999?
Provide a succinct answer. 0.9. What is the ratio of the ODA received (in %) of Fiji in 1998 to that in 1999?
Your answer should be compact. 1. What is the ratio of the ODA received (in %) in Niger in 1998 to that in 1999?
Ensure brevity in your answer.  1.38. What is the ratio of the ODA received (in %) in Least developed countries in 1998 to that in 2000?
Provide a short and direct response. 1.21. What is the ratio of the ODA received (in %) in Fiji in 1998 to that in 2000?
Ensure brevity in your answer.  0.79. What is the ratio of the ODA received (in %) in Niger in 1998 to that in 2000?
Your answer should be very brief. 1.23. What is the ratio of the ODA received (in %) in Least developed countries in 1998 to that in 2001?
Your answer should be compact. 1.07. What is the ratio of the ODA received (in %) in Other small states in 1998 to that in 2001?
Offer a terse response. 1.22. What is the ratio of the ODA received (in %) in Fiji in 1998 to that in 2001?
Offer a very short reply. 0.81. What is the ratio of the ODA received (in %) in Niger in 1998 to that in 2001?
Your answer should be very brief. 1.14. What is the ratio of the ODA received (in %) of Least developed countries in 1998 to that in 2002?
Your response must be concise. 0.94. What is the ratio of the ODA received (in %) of Other small states in 1998 to that in 2002?
Offer a very short reply. 0.82. What is the ratio of the ODA received (in %) of Fiji in 1998 to that in 2002?
Provide a short and direct response. 0.83. What is the ratio of the ODA received (in %) of Niger in 1998 to that in 2002?
Offer a terse response. 1.28. What is the ratio of the ODA received (in %) of Least developed countries in 1998 to that in 2003?
Your response must be concise. 0.85. What is the ratio of the ODA received (in %) in Other small states in 1998 to that in 2003?
Provide a succinct answer. 1.24. What is the ratio of the ODA received (in %) of Fiji in 1998 to that in 2003?
Your answer should be compact. 0.79. What is the ratio of the ODA received (in %) of Niger in 1998 to that in 2003?
Offer a very short reply. 1.12. What is the ratio of the ODA received (in %) in Least developed countries in 1999 to that in 2000?
Offer a very short reply. 1.14. What is the ratio of the ODA received (in %) in Other small states in 1999 to that in 2000?
Give a very brief answer. 1.1. What is the ratio of the ODA received (in %) in Fiji in 1999 to that in 2000?
Ensure brevity in your answer.  0.79. What is the ratio of the ODA received (in %) of Niger in 1999 to that in 2000?
Provide a short and direct response. 0.89. What is the ratio of the ODA received (in %) in Least developed countries in 1999 to that in 2001?
Your answer should be very brief. 1.01. What is the ratio of the ODA received (in %) of Other small states in 1999 to that in 2001?
Keep it short and to the point. 1.35. What is the ratio of the ODA received (in %) in Fiji in 1999 to that in 2001?
Provide a succinct answer. 0.81. What is the ratio of the ODA received (in %) in Niger in 1999 to that in 2001?
Provide a succinct answer. 0.83. What is the ratio of the ODA received (in %) of Least developed countries in 1999 to that in 2002?
Offer a very short reply. 0.89. What is the ratio of the ODA received (in %) in Other small states in 1999 to that in 2002?
Provide a short and direct response. 0.91. What is the ratio of the ODA received (in %) of Fiji in 1999 to that in 2002?
Your answer should be compact. 0.83. What is the ratio of the ODA received (in %) of Niger in 1999 to that in 2002?
Ensure brevity in your answer.  0.93. What is the ratio of the ODA received (in %) in Least developed countries in 1999 to that in 2003?
Your answer should be compact. 0.8. What is the ratio of the ODA received (in %) of Other small states in 1999 to that in 2003?
Provide a succinct answer. 1.38. What is the ratio of the ODA received (in %) in Fiji in 1999 to that in 2003?
Offer a terse response. 0.79. What is the ratio of the ODA received (in %) in Niger in 1999 to that in 2003?
Offer a terse response. 0.81. What is the ratio of the ODA received (in %) of Least developed countries in 2000 to that in 2001?
Offer a terse response. 0.89. What is the ratio of the ODA received (in %) in Other small states in 2000 to that in 2001?
Ensure brevity in your answer.  1.23. What is the ratio of the ODA received (in %) in Fiji in 2000 to that in 2001?
Make the answer very short. 1.03. What is the ratio of the ODA received (in %) in Niger in 2000 to that in 2001?
Give a very brief answer. 0.93. What is the ratio of the ODA received (in %) of Least developed countries in 2000 to that in 2002?
Make the answer very short. 0.78. What is the ratio of the ODA received (in %) of Other small states in 2000 to that in 2002?
Ensure brevity in your answer.  0.83. What is the ratio of the ODA received (in %) of Fiji in 2000 to that in 2002?
Offer a terse response. 1.06. What is the ratio of the ODA received (in %) of Niger in 2000 to that in 2002?
Offer a very short reply. 1.04. What is the ratio of the ODA received (in %) in Least developed countries in 2000 to that in 2003?
Make the answer very short. 0.7. What is the ratio of the ODA received (in %) of Other small states in 2000 to that in 2003?
Provide a short and direct response. 1.25. What is the ratio of the ODA received (in %) in Fiji in 2000 to that in 2003?
Provide a succinct answer. 1. What is the ratio of the ODA received (in %) in Niger in 2000 to that in 2003?
Make the answer very short. 0.91. What is the ratio of the ODA received (in %) in Least developed countries in 2001 to that in 2002?
Provide a short and direct response. 0.88. What is the ratio of the ODA received (in %) of Other small states in 2001 to that in 2002?
Provide a succinct answer. 0.67. What is the ratio of the ODA received (in %) of Fiji in 2001 to that in 2002?
Offer a very short reply. 1.02. What is the ratio of the ODA received (in %) in Niger in 2001 to that in 2002?
Your response must be concise. 1.13. What is the ratio of the ODA received (in %) of Least developed countries in 2001 to that in 2003?
Give a very brief answer. 0.79. What is the ratio of the ODA received (in %) of Other small states in 2001 to that in 2003?
Your answer should be very brief. 1.02. What is the ratio of the ODA received (in %) of Fiji in 2001 to that in 2003?
Provide a succinct answer. 0.96. What is the ratio of the ODA received (in %) in Niger in 2001 to that in 2003?
Ensure brevity in your answer.  0.99. What is the ratio of the ODA received (in %) in Least developed countries in 2002 to that in 2003?
Provide a succinct answer. 0.9. What is the ratio of the ODA received (in %) of Other small states in 2002 to that in 2003?
Offer a terse response. 1.52. What is the ratio of the ODA received (in %) in Fiji in 2002 to that in 2003?
Provide a short and direct response. 0.94. What is the ratio of the ODA received (in %) in Niger in 2002 to that in 2003?
Ensure brevity in your answer.  0.88. What is the difference between the highest and the second highest ODA received (in %) of Least developed countries?
Offer a very short reply. 0.07. What is the difference between the highest and the second highest ODA received (in %) in Other small states?
Ensure brevity in your answer.  2.18. What is the difference between the highest and the second highest ODA received (in %) of Fiji?
Provide a short and direct response. 1.57. What is the difference between the highest and the second highest ODA received (in %) in Niger?
Offer a terse response. 34.87. What is the difference between the highest and the lowest ODA received (in %) in Least developed countries?
Offer a very short reply. 12.26. What is the difference between the highest and the lowest ODA received (in %) in Other small states?
Your answer should be compact. 7.17. What is the difference between the highest and the lowest ODA received (in %) in Fiji?
Keep it short and to the point. 5.28. What is the difference between the highest and the lowest ODA received (in %) of Niger?
Provide a short and direct response. 75.53. 